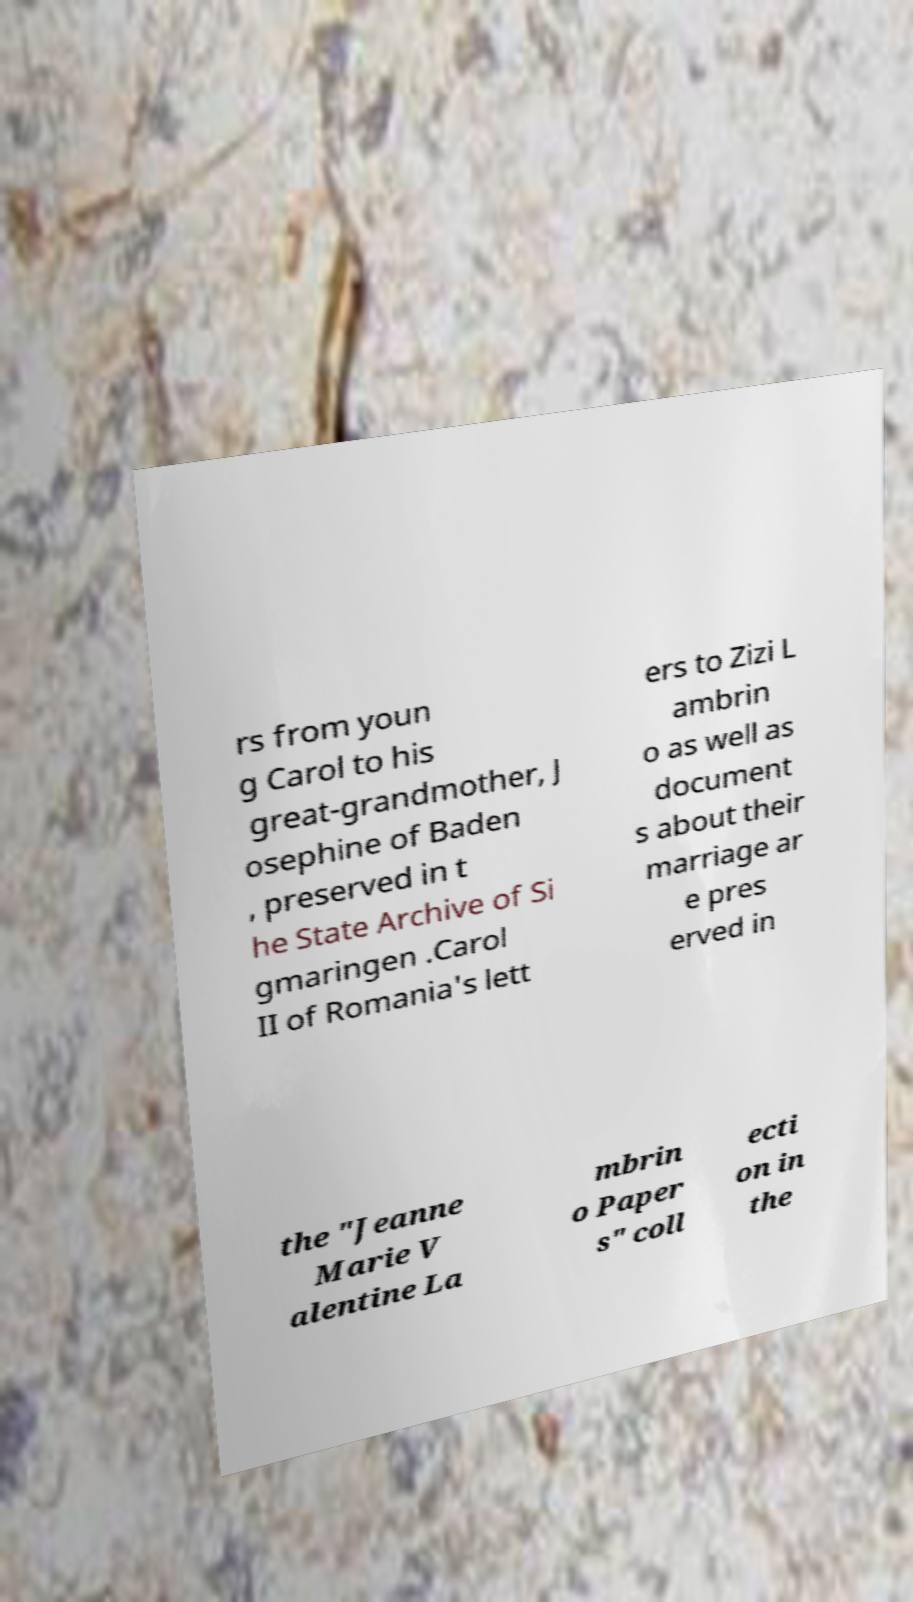Please identify and transcribe the text found in this image. rs from youn g Carol to his great-grandmother, J osephine of Baden , preserved in t he State Archive of Si gmaringen .Carol II of Romania's lett ers to Zizi L ambrin o as well as document s about their marriage ar e pres erved in the "Jeanne Marie V alentine La mbrin o Paper s" coll ecti on in the 